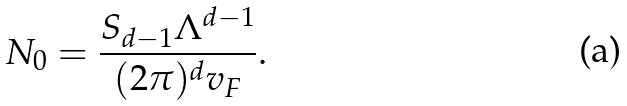Convert formula to latex. <formula><loc_0><loc_0><loc_500><loc_500>N _ { 0 } = { \frac { S _ { d - 1 } \Lambda ^ { d - 1 } } { ( 2 \pi ) ^ { d } v _ { F } } } .</formula> 